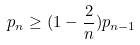Convert formula to latex. <formula><loc_0><loc_0><loc_500><loc_500>p _ { n } \geq ( 1 - \frac { 2 } { n } ) p _ { n - 1 }</formula> 